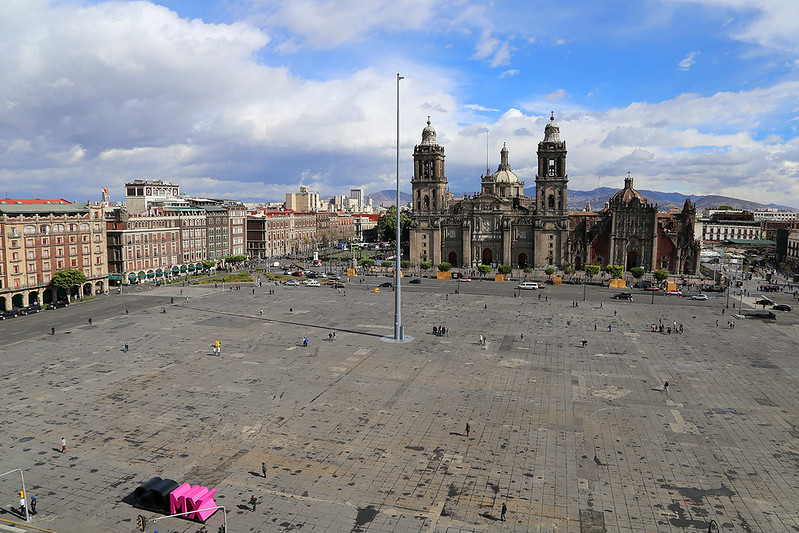Imagine if the Zócalo could talk. What stories would it tell? If the Zócalo could talk, it would weave tales of triumph and turmoil, of grand celebrations and solemn protests. It would recount the days when the Aztec Empire thrived, the sacred rituals performed at the Templo Mayor. It would speak of the Spanish conquest, the rebuilding of the city, and the centuries of colonial rule.

The Zócalo would tell stories of independence, the cries for freedom ringing through its open expanse, and the dawn of the Mexican Republic. It would narrate the vibrant fiestas, the parades, and the cultural events that have brought people together. It would also share the quiet moments, the times of reflection for those who come to bask in its historic aura.

From the ancient Aztecs' chants to the modern-day mariachi band performances, if the Zócalo could talk, it would be a living archive of Mexico City's soul, resonating with the echoes of its past and the pulsating heartbeat of its present. 